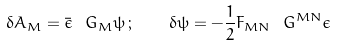<formula> <loc_0><loc_0><loc_500><loc_500>\delta A _ { M } = \bar { \epsilon } \ G _ { M } \psi \, ; \quad \delta \psi = - \frac { 1 } { 2 } F _ { M N } \ G ^ { M N } \epsilon</formula> 